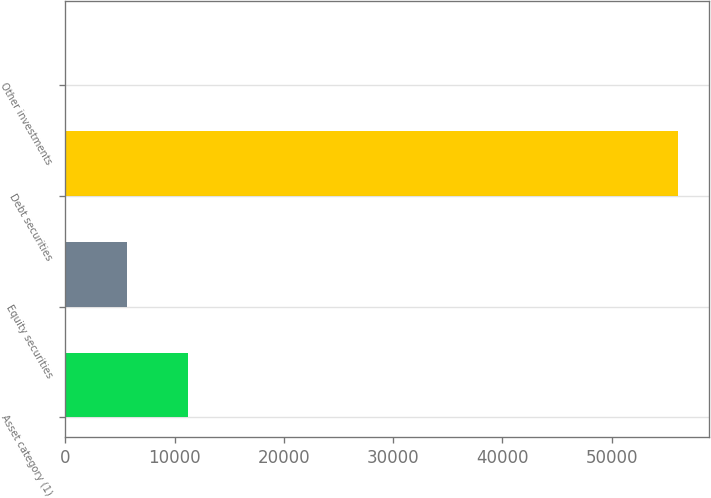<chart> <loc_0><loc_0><loc_500><loc_500><bar_chart><fcel>Asset category (1)<fcel>Equity securities<fcel>Debt securities<fcel>Other investments<nl><fcel>11222.4<fcel>5612.7<fcel>56100<fcel>3<nl></chart> 